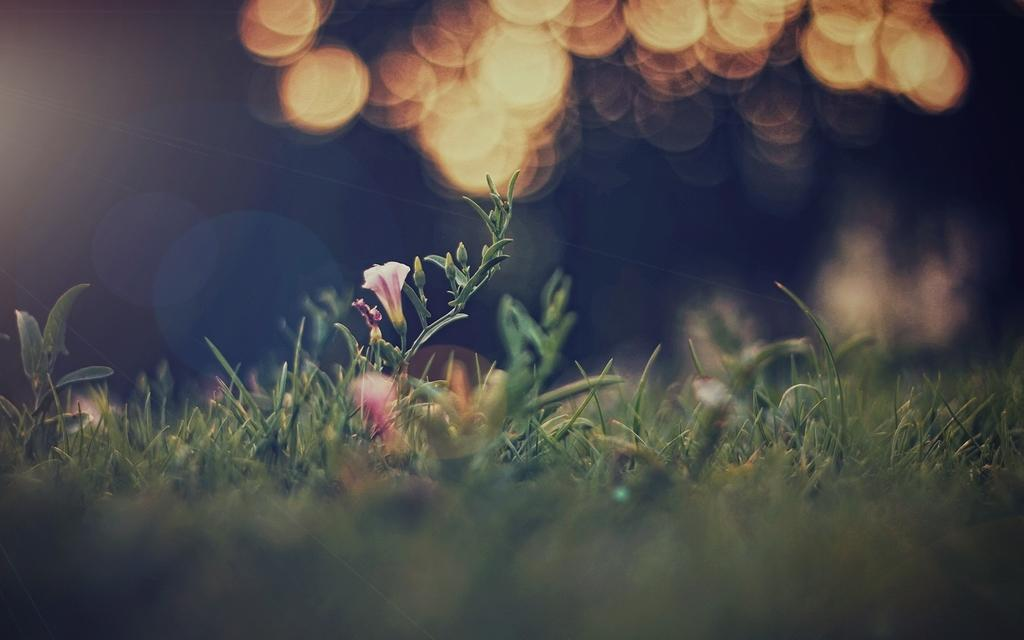What type of living organisms can be seen in the image? There are flowers in the image. What material is present at the bottom of the image? There is glass at the bottom of the image. What can be seen at the top of the image? There are lights visible at the top of the image. What type of music is being played by the team in the image? There is no music or team present in the image; it features flowers, glass, and lights. 